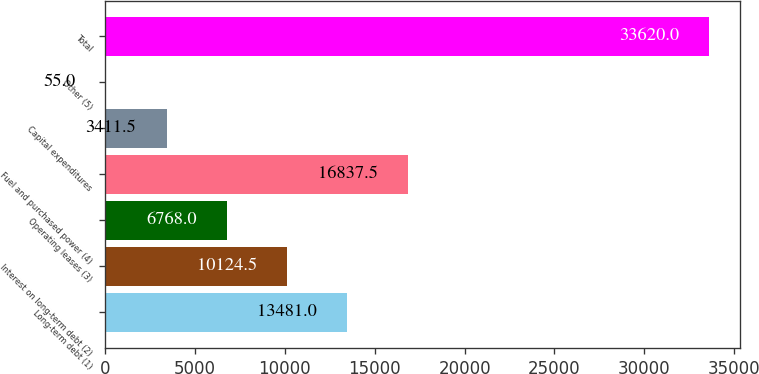Convert chart to OTSL. <chart><loc_0><loc_0><loc_500><loc_500><bar_chart><fcel>Long-term debt (1)<fcel>Interest on long-term debt (2)<fcel>Operating leases (3)<fcel>Fuel and purchased power (4)<fcel>Capital expenditures<fcel>Other (5)<fcel>Total<nl><fcel>13481<fcel>10124.5<fcel>6768<fcel>16837.5<fcel>3411.5<fcel>55<fcel>33620<nl></chart> 